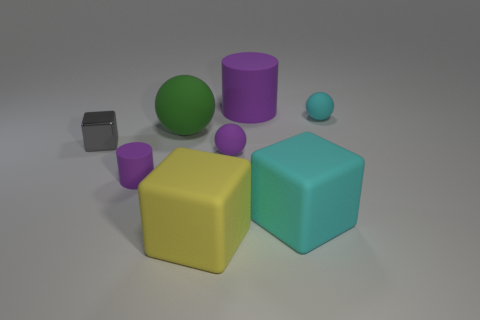There is a tiny thing that is the same color as the small rubber cylinder; what is its shape?
Your response must be concise. Sphere. What number of objects are either tiny metallic blocks or small purple matte objects?
Provide a short and direct response. 3. Is the number of small gray things that are behind the tiny gray metallic cube the same as the number of small red metal blocks?
Give a very brief answer. Yes. There is a purple rubber cylinder that is to the left of the matte cylinder that is right of the large yellow rubber thing; are there any small cylinders left of it?
Keep it short and to the point. No. The tiny cylinder that is made of the same material as the cyan sphere is what color?
Make the answer very short. Purple. There is a cylinder behind the metallic cube; does it have the same color as the large rubber ball?
Offer a terse response. No. What number of cubes are either large green things or small gray objects?
Your answer should be very brief. 1. There is a sphere right of the purple rubber thing that is behind the tiny thing that is to the right of the small purple sphere; how big is it?
Give a very brief answer. Small. There is a purple matte thing that is the same size as the yellow matte thing; what shape is it?
Give a very brief answer. Cylinder. There is a green object; what shape is it?
Keep it short and to the point. Sphere. 